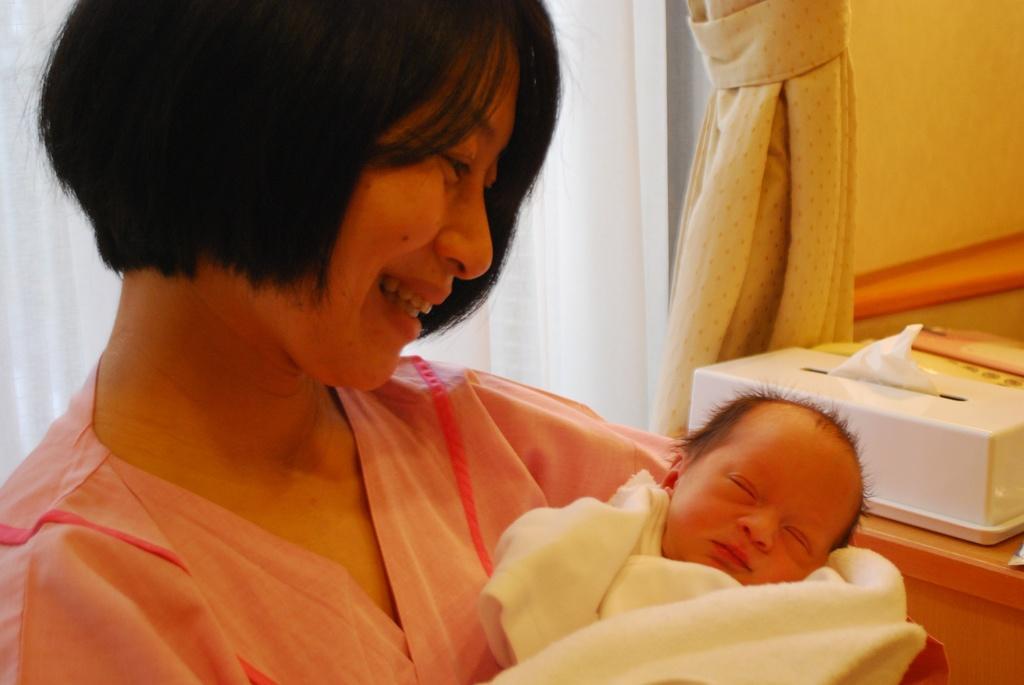Describe this image in one or two sentences. In this image we can see a lady holding a baby in her hands, where she is wearing a pink color dress and she has short hair. On the right side of the image we have tissues and curtain. 